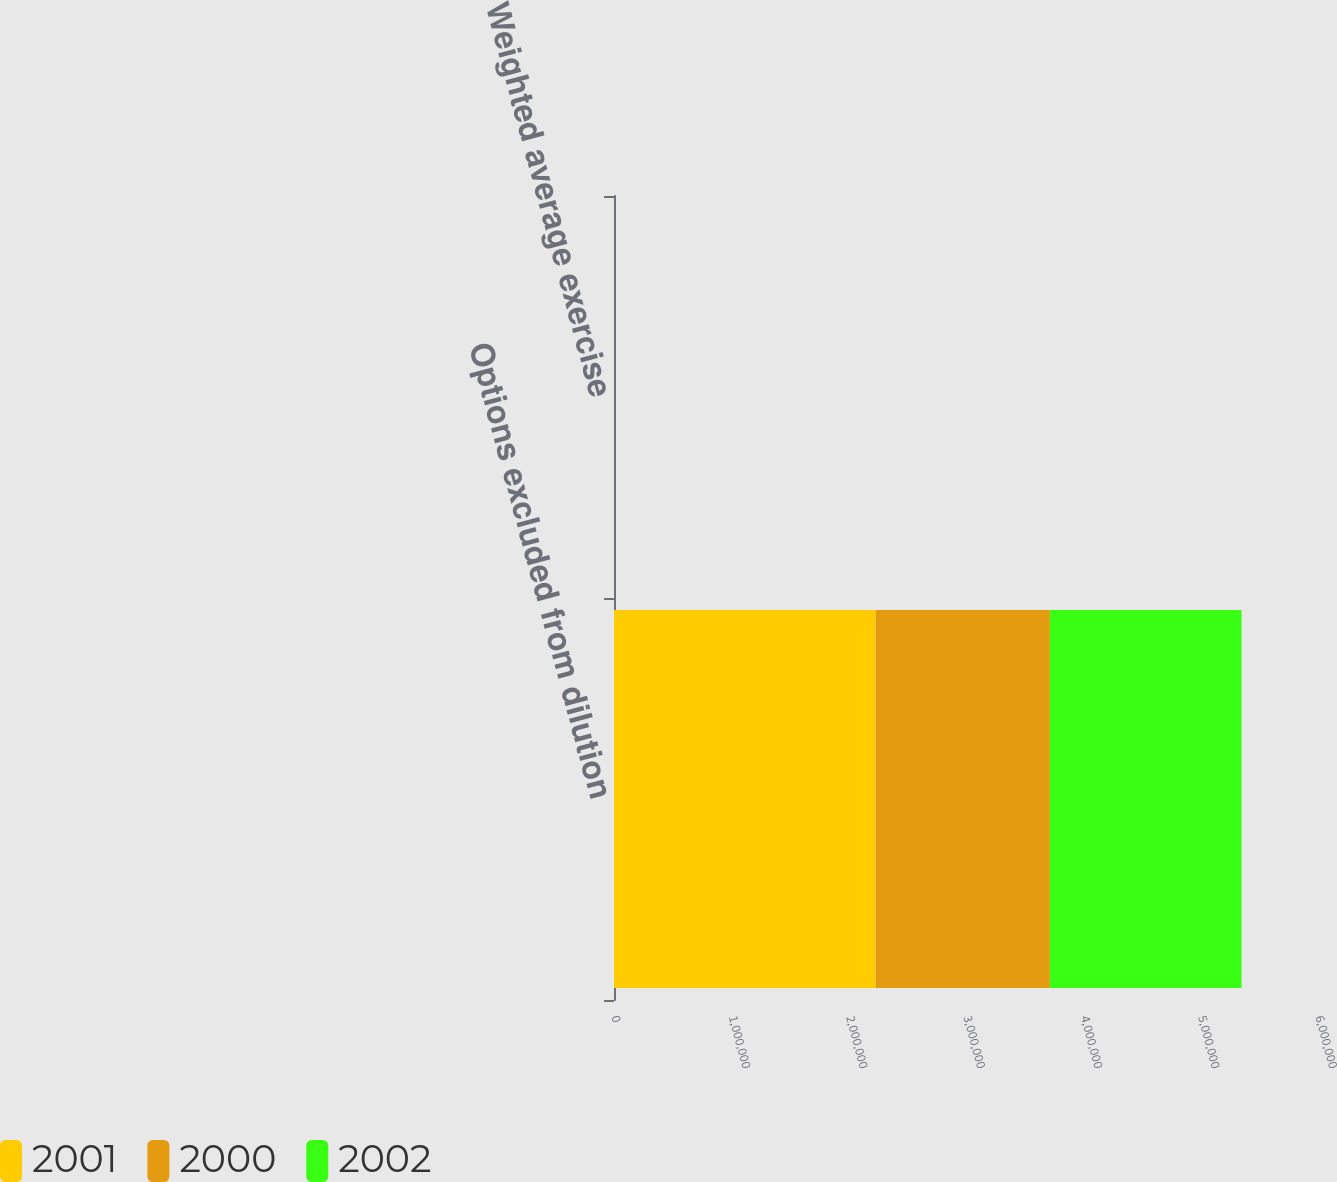<chart> <loc_0><loc_0><loc_500><loc_500><stacked_bar_chart><ecel><fcel>Options excluded from dilution<fcel>Weighted average exercise<nl><fcel>2001<fcel>2.22998e+06<fcel>39.77<nl><fcel>2000<fcel>1.4853e+06<fcel>41.29<nl><fcel>2002<fcel>1.63315e+06<fcel>38.39<nl></chart> 